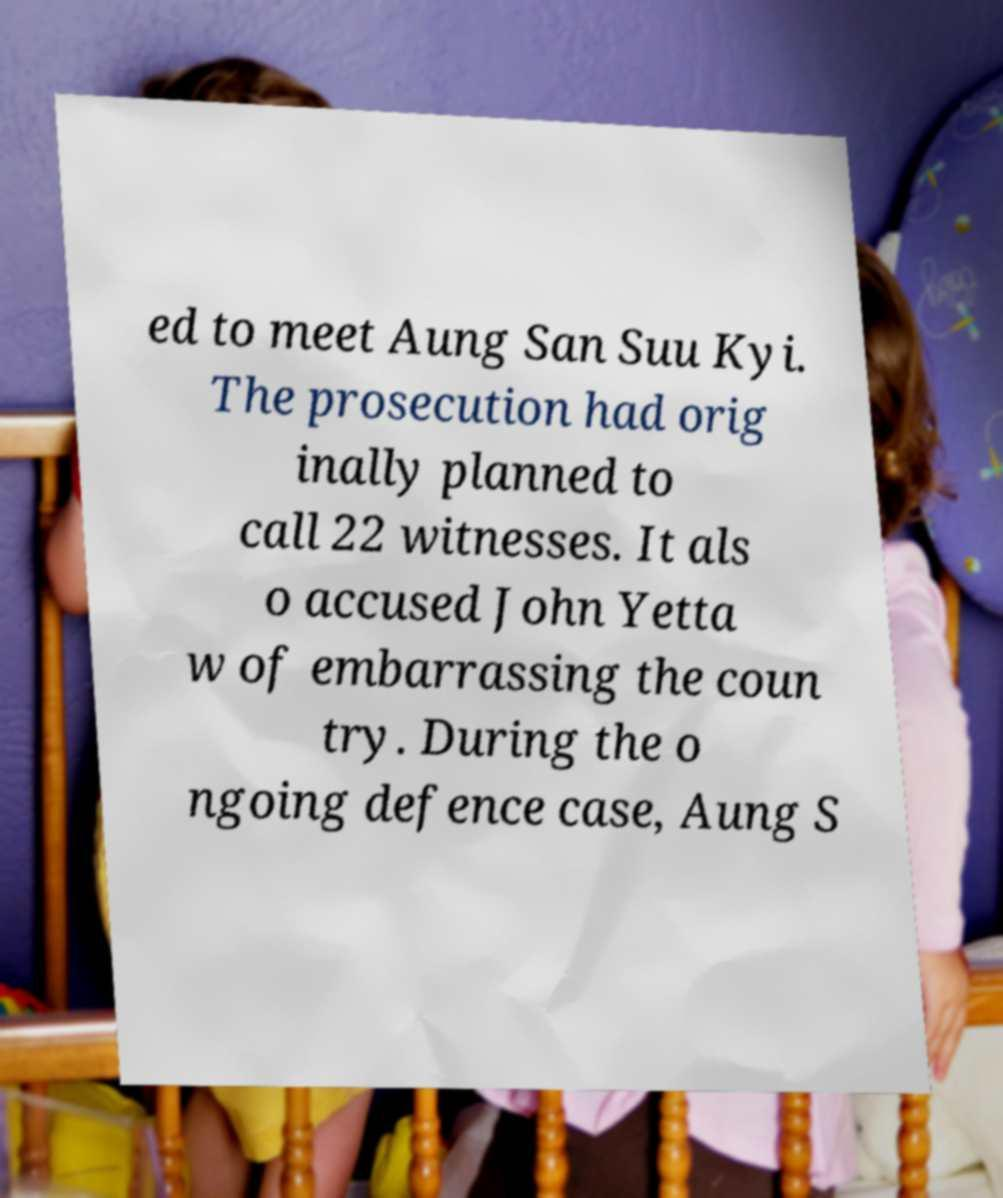Could you assist in decoding the text presented in this image and type it out clearly? ed to meet Aung San Suu Kyi. The prosecution had orig inally planned to call 22 witnesses. It als o accused John Yetta w of embarrassing the coun try. During the o ngoing defence case, Aung S 